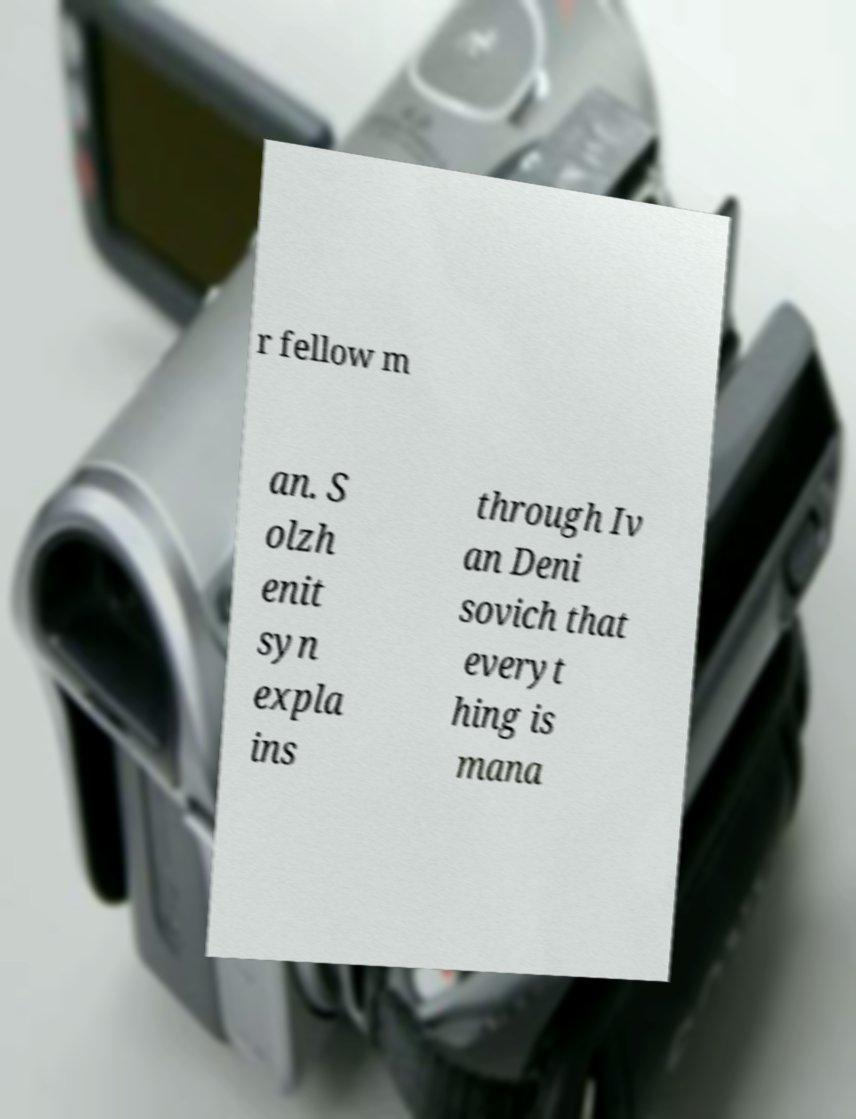Can you accurately transcribe the text from the provided image for me? r fellow m an. S olzh enit syn expla ins through Iv an Deni sovich that everyt hing is mana 